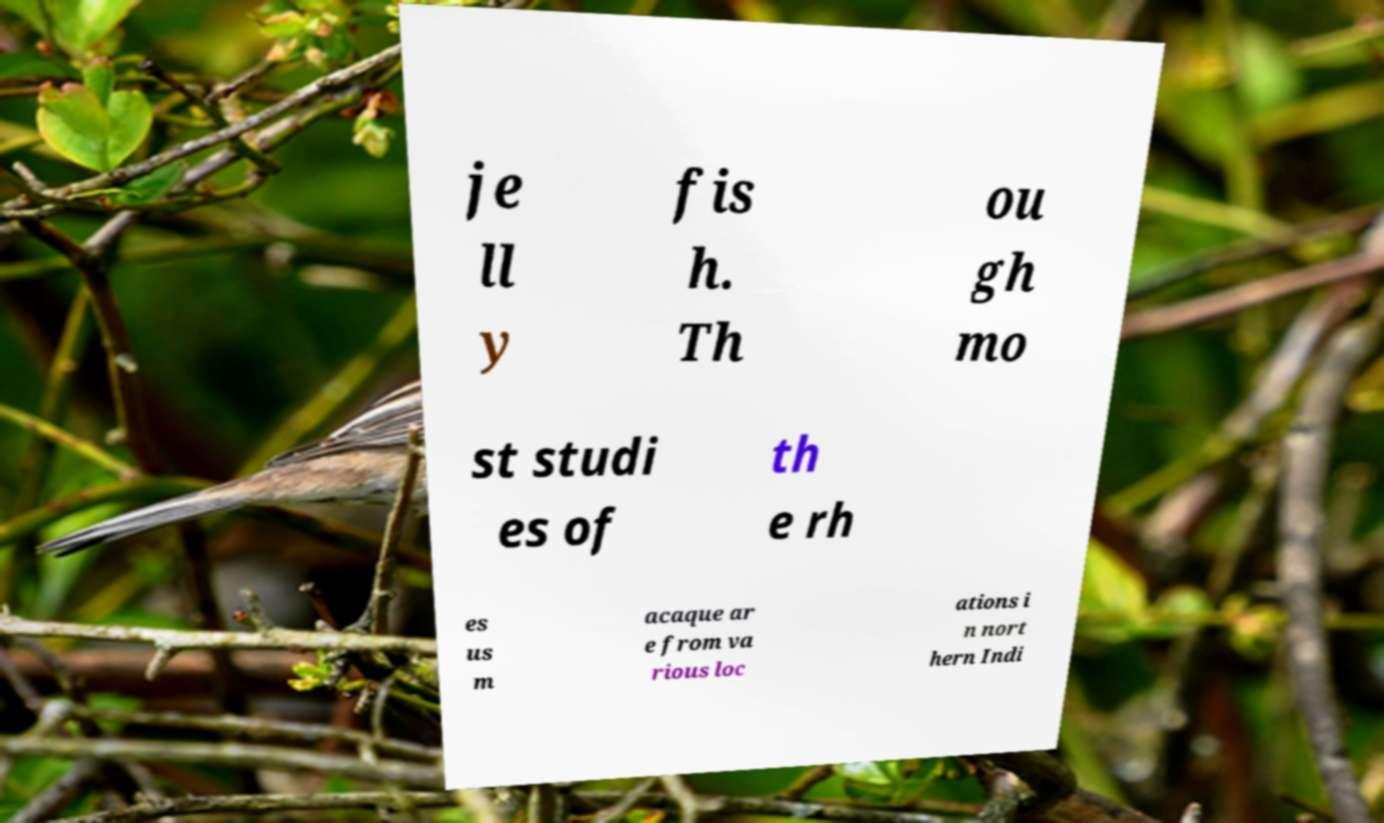Can you read and provide the text displayed in the image?This photo seems to have some interesting text. Can you extract and type it out for me? je ll y fis h. Th ou gh mo st studi es of th e rh es us m acaque ar e from va rious loc ations i n nort hern Indi 